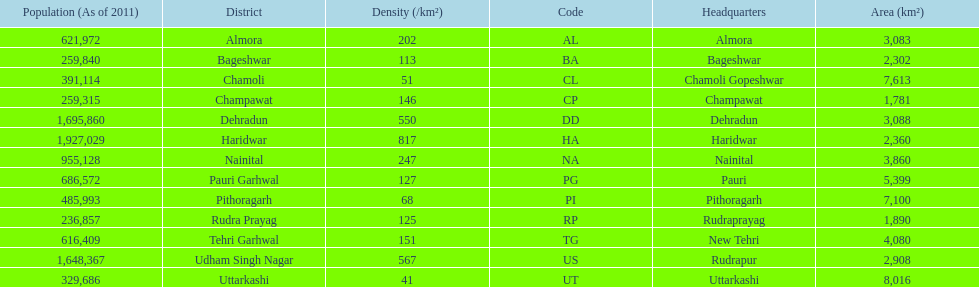How many total districts are there in this area? 13. 